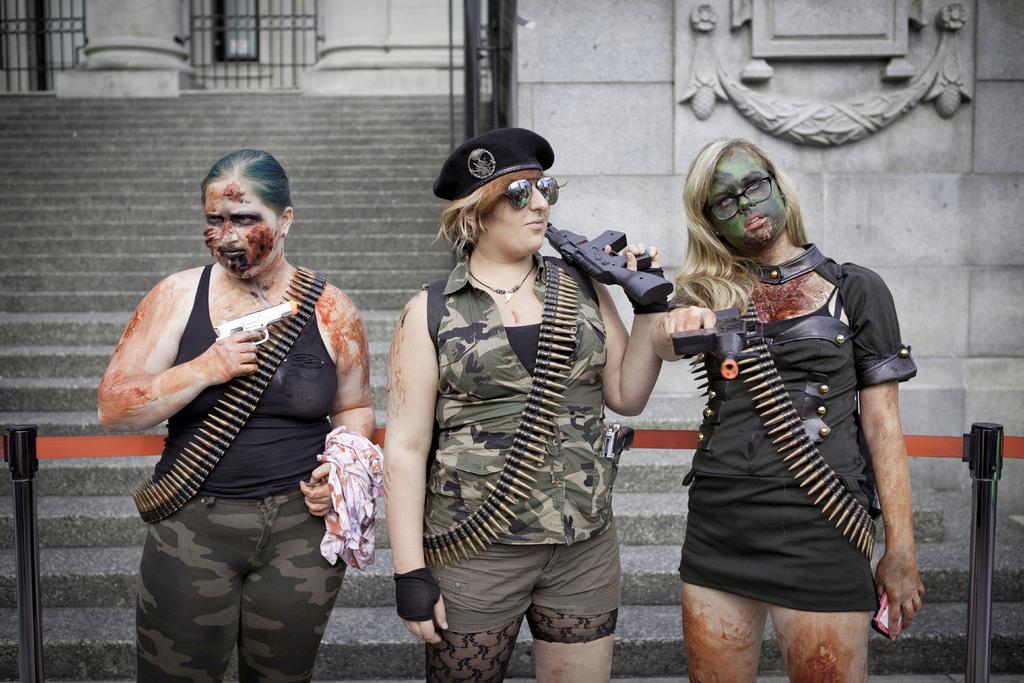In one or two sentences, can you explain what this image depicts? In the image there are three ladies standing and they are wearing bullet chains and holding guns. In the middle of them there is a lady with a hat and goggles. Behind them there are poles with red object and there is a wall with sculpture. And also there are steps, pillars and fencing. 